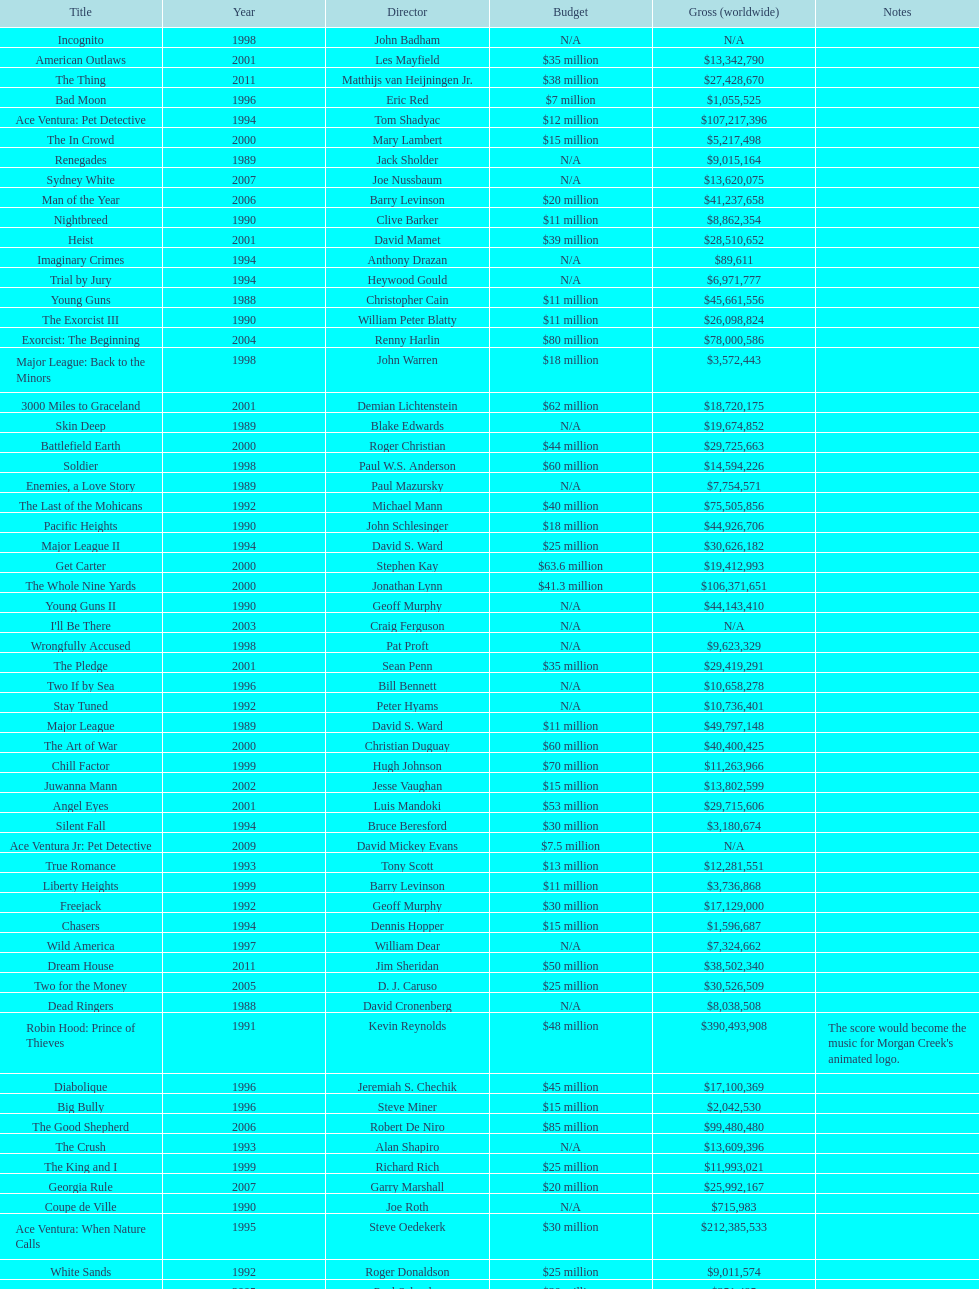After young guns, what was the next movie with the exact same budget? Major League. Give me the full table as a dictionary. {'header': ['Title', 'Year', 'Director', 'Budget', 'Gross (worldwide)', 'Notes'], 'rows': [['Incognito', '1998', 'John Badham', 'N/A', 'N/A', ''], ['American Outlaws', '2001', 'Les Mayfield', '$35 million', '$13,342,790', ''], ['The Thing', '2011', 'Matthijs van Heijningen Jr.', '$38 million', '$27,428,670', ''], ['Bad Moon', '1996', 'Eric Red', '$7 million', '$1,055,525', ''], ['Ace Ventura: Pet Detective', '1994', 'Tom Shadyac', '$12 million', '$107,217,396', ''], ['The In Crowd', '2000', 'Mary Lambert', '$15 million', '$5,217,498', ''], ['Renegades', '1989', 'Jack Sholder', 'N/A', '$9,015,164', ''], ['Sydney White', '2007', 'Joe Nussbaum', 'N/A', '$13,620,075', ''], ['Man of the Year', '2006', 'Barry Levinson', '$20 million', '$41,237,658', ''], ['Nightbreed', '1990', 'Clive Barker', '$11 million', '$8,862,354', ''], ['Heist', '2001', 'David Mamet', '$39 million', '$28,510,652', ''], ['Imaginary Crimes', '1994', 'Anthony Drazan', 'N/A', '$89,611', ''], ['Trial by Jury', '1994', 'Heywood Gould', 'N/A', '$6,971,777', ''], ['Young Guns', '1988', 'Christopher Cain', '$11 million', '$45,661,556', ''], ['The Exorcist III', '1990', 'William Peter Blatty', '$11 million', '$26,098,824', ''], ['Exorcist: The Beginning', '2004', 'Renny Harlin', '$80 million', '$78,000,586', ''], ['Major League: Back to the Minors', '1998', 'John Warren', '$18 million', '$3,572,443', ''], ['3000 Miles to Graceland', '2001', 'Demian Lichtenstein', '$62 million', '$18,720,175', ''], ['Skin Deep', '1989', 'Blake Edwards', 'N/A', '$19,674,852', ''], ['Battlefield Earth', '2000', 'Roger Christian', '$44 million', '$29,725,663', ''], ['Soldier', '1998', 'Paul W.S. Anderson', '$60 million', '$14,594,226', ''], ['Enemies, a Love Story', '1989', 'Paul Mazursky', 'N/A', '$7,754,571', ''], ['The Last of the Mohicans', '1992', 'Michael Mann', '$40 million', '$75,505,856', ''], ['Pacific Heights', '1990', 'John Schlesinger', '$18 million', '$44,926,706', ''], ['Major League II', '1994', 'David S. Ward', '$25 million', '$30,626,182', ''], ['Get Carter', '2000', 'Stephen Kay', '$63.6 million', '$19,412,993', ''], ['The Whole Nine Yards', '2000', 'Jonathan Lynn', '$41.3 million', '$106,371,651', ''], ['Young Guns II', '1990', 'Geoff Murphy', 'N/A', '$44,143,410', ''], ["I'll Be There", '2003', 'Craig Ferguson', 'N/A', 'N/A', ''], ['Wrongfully Accused', '1998', 'Pat Proft', 'N/A', '$9,623,329', ''], ['The Pledge', '2001', 'Sean Penn', '$35 million', '$29,419,291', ''], ['Two If by Sea', '1996', 'Bill Bennett', 'N/A', '$10,658,278', ''], ['Stay Tuned', '1992', 'Peter Hyams', 'N/A', '$10,736,401', ''], ['Major League', '1989', 'David S. Ward', '$11 million', '$49,797,148', ''], ['The Art of War', '2000', 'Christian Duguay', '$60 million', '$40,400,425', ''], ['Chill Factor', '1999', 'Hugh Johnson', '$70 million', '$11,263,966', ''], ['Juwanna Mann', '2002', 'Jesse Vaughan', '$15 million', '$13,802,599', ''], ['Angel Eyes', '2001', 'Luis Mandoki', '$53 million', '$29,715,606', ''], ['Silent Fall', '1994', 'Bruce Beresford', '$30 million', '$3,180,674', ''], ['Ace Ventura Jr: Pet Detective', '2009', 'David Mickey Evans', '$7.5 million', 'N/A', ''], ['True Romance', '1993', 'Tony Scott', '$13 million', '$12,281,551', ''], ['Liberty Heights', '1999', 'Barry Levinson', '$11 million', '$3,736,868', ''], ['Freejack', '1992', 'Geoff Murphy', '$30 million', '$17,129,000', ''], ['Chasers', '1994', 'Dennis Hopper', '$15 million', '$1,596,687', ''], ['Wild America', '1997', 'William Dear', 'N/A', '$7,324,662', ''], ['Dream House', '2011', 'Jim Sheridan', '$50 million', '$38,502,340', ''], ['Two for the Money', '2005', 'D. J. Caruso', '$25 million', '$30,526,509', ''], ['Dead Ringers', '1988', 'David Cronenberg', 'N/A', '$8,038,508', ''], ['Robin Hood: Prince of Thieves', '1991', 'Kevin Reynolds', '$48 million', '$390,493,908', "The score would become the music for Morgan Creek's animated logo."], ['Diabolique', '1996', 'Jeremiah S. Chechik', '$45 million', '$17,100,369', ''], ['Big Bully', '1996', 'Steve Miner', '$15 million', '$2,042,530', ''], ['The Good Shepherd', '2006', 'Robert De Niro', '$85 million', '$99,480,480', ''], ['The Crush', '1993', 'Alan Shapiro', 'N/A', '$13,609,396', ''], ['The King and I', '1999', 'Richard Rich', '$25 million', '$11,993,021', ''], ['Georgia Rule', '2007', 'Garry Marshall', '$20 million', '$25,992,167', ''], ['Coupe de Ville', '1990', 'Joe Roth', 'N/A', '$715,983', ''], ['Ace Ventura: When Nature Calls', '1995', 'Steve Oedekerk', '$30 million', '$212,385,533', ''], ['White Sands', '1992', 'Roger Donaldson', '$25 million', '$9,011,574', ''], ['Dominion: Prequel to the Exorcist', '2005', 'Paul Schrader', '$30 million', '$251,495', ''], ['Tupac', '2014', 'Antoine Fuqua', '$45 million', '', '']]} 